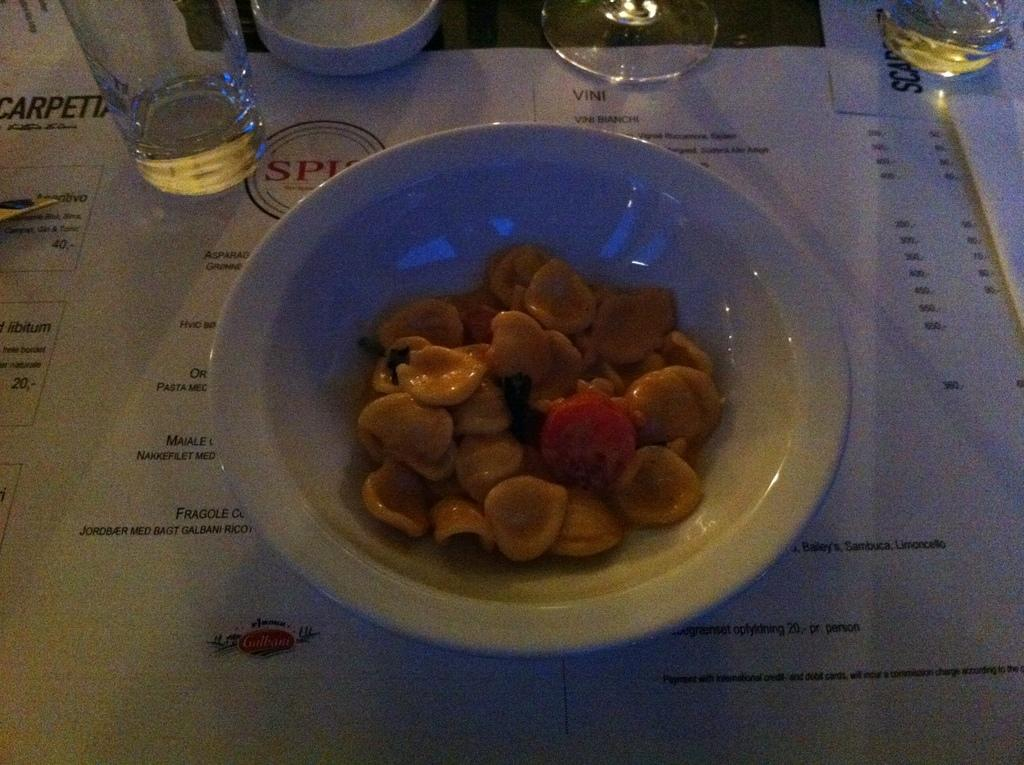What type of furniture is present in the image? There is a table in the image. What can be found on the table? There is a menu card with text and a food item in a bowl on the table. What might be used for drinking in the image? There are glasses on the table. What type of government is depicted on the pig in the image? There is no pig present in the image, and therefore no government can be depicted on it. 